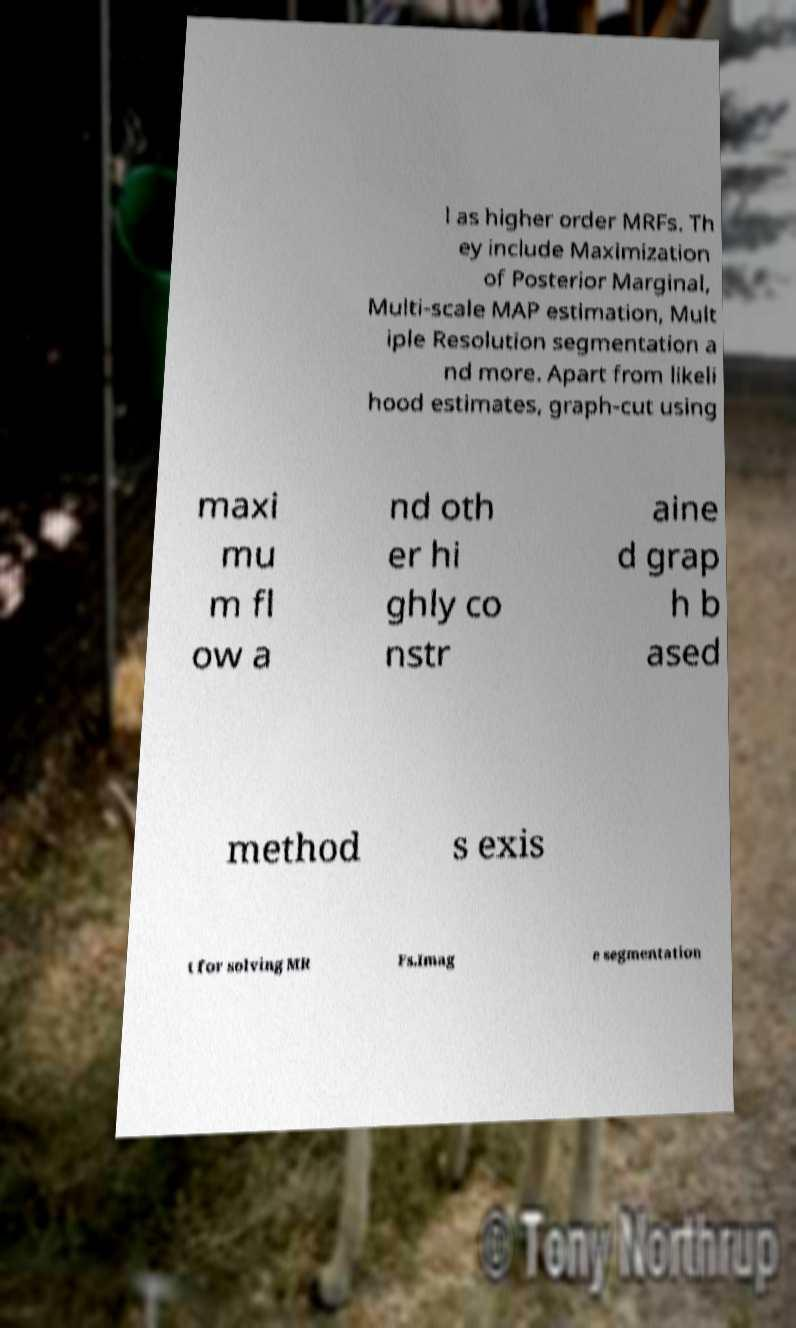What messages or text are displayed in this image? I need them in a readable, typed format. l as higher order MRFs. Th ey include Maximization of Posterior Marginal, Multi-scale MAP estimation, Mult iple Resolution segmentation a nd more. Apart from likeli hood estimates, graph-cut using maxi mu m fl ow a nd oth er hi ghly co nstr aine d grap h b ased method s exis t for solving MR Fs.Imag e segmentation 